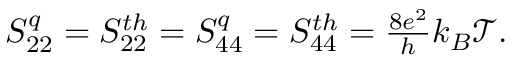<formula> <loc_0><loc_0><loc_500><loc_500>\begin{array} { r } { S _ { 2 2 } ^ { q } = { S _ { 2 2 } ^ { t h } } = S _ { 4 4 } ^ { q } = { S _ { 4 4 } ^ { t h } } = \frac { 8 e ^ { 2 } } { h } k _ { B } \mathcal { T } . } \end{array}</formula> 